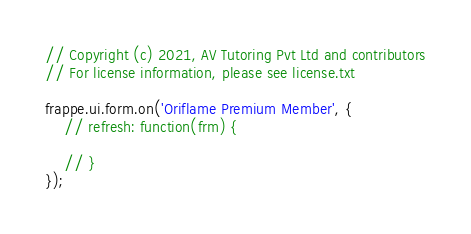<code> <loc_0><loc_0><loc_500><loc_500><_JavaScript_>// Copyright (c) 2021, AV Tutoring Pvt Ltd and contributors
// For license information, please see license.txt

frappe.ui.form.on('Oriflame Premium Member', {
	// refresh: function(frm) {

	// }
});
</code> 